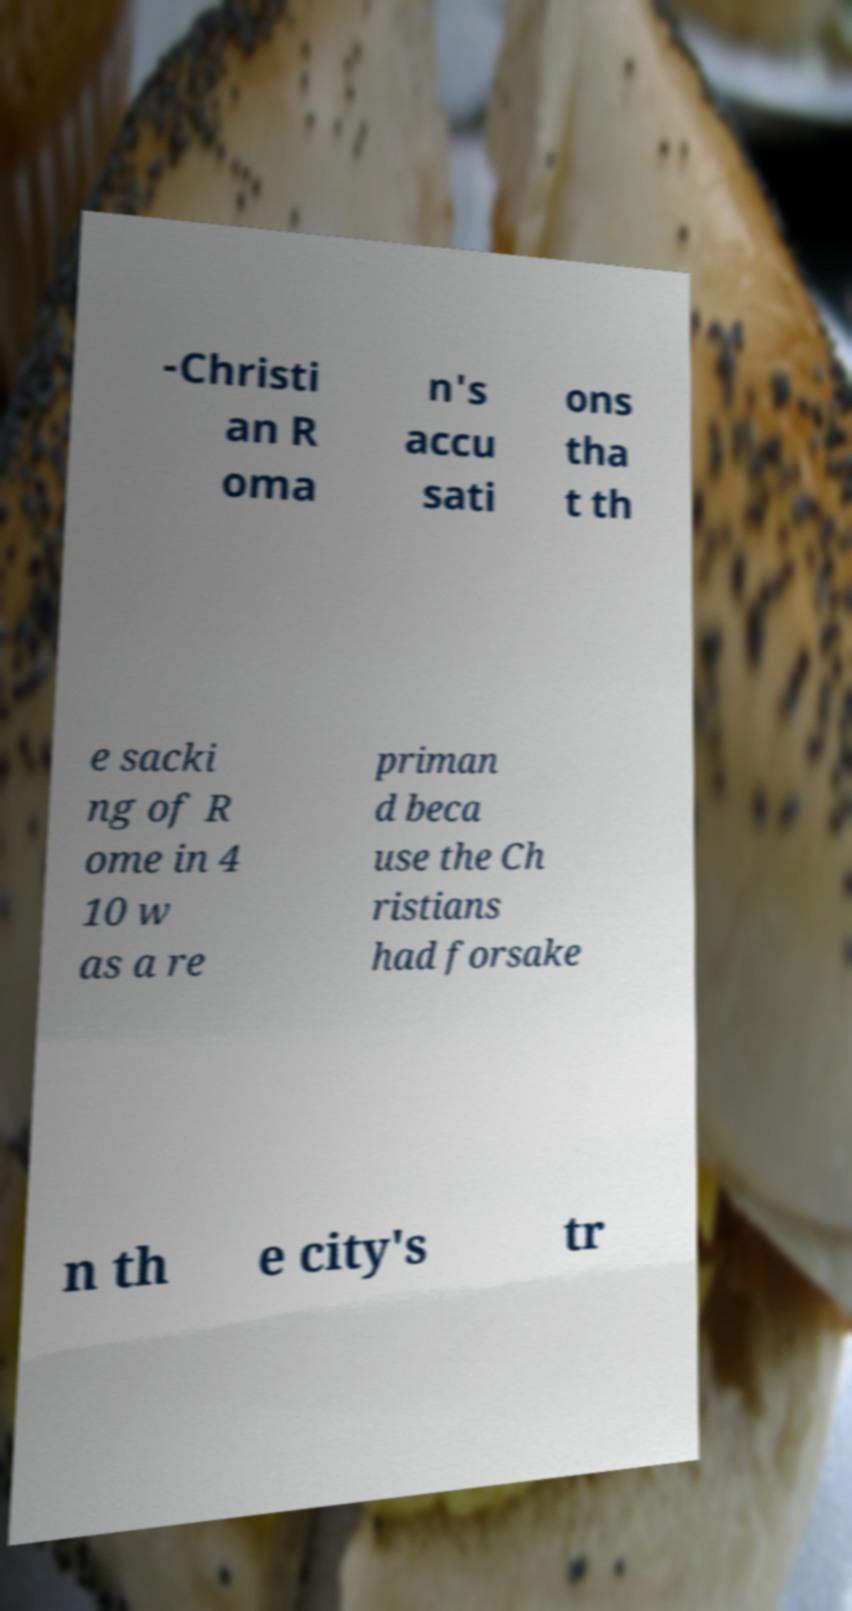Please read and relay the text visible in this image. What does it say? -Christi an R oma n's accu sati ons tha t th e sacki ng of R ome in 4 10 w as a re priman d beca use the Ch ristians had forsake n th e city's tr 